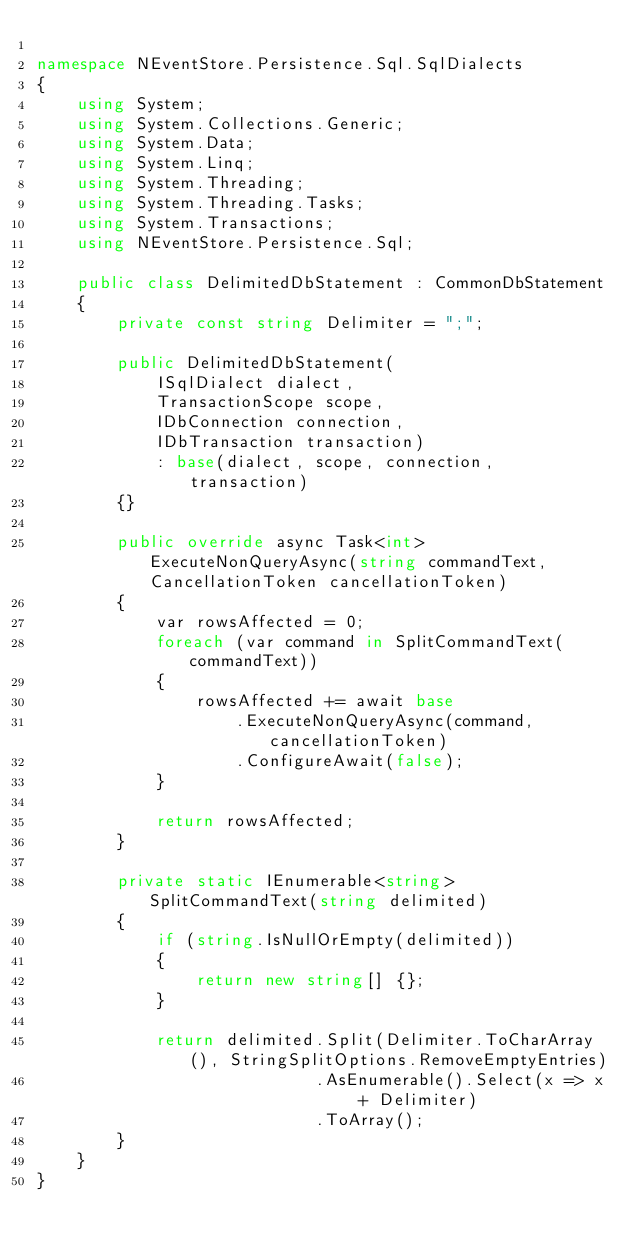<code> <loc_0><loc_0><loc_500><loc_500><_C#_>
namespace NEventStore.Persistence.Sql.SqlDialects
{
    using System;
    using System.Collections.Generic;
    using System.Data;
    using System.Linq;
    using System.Threading;
    using System.Threading.Tasks;
    using System.Transactions;
    using NEventStore.Persistence.Sql;

    public class DelimitedDbStatement : CommonDbStatement
    {
        private const string Delimiter = ";";

        public DelimitedDbStatement(
            ISqlDialect dialect,
            TransactionScope scope,
            IDbConnection connection,
            IDbTransaction transaction)
            : base(dialect, scope, connection, transaction)
        {}

        public override async Task<int> ExecuteNonQueryAsync(string commandText, CancellationToken cancellationToken)
        {
            var rowsAffected = 0;
            foreach (var command in SplitCommandText(commandText))
            {
                rowsAffected += await base
                    .ExecuteNonQueryAsync(command, cancellationToken)
                    .ConfigureAwait(false);
            }

            return rowsAffected;
        }

        private static IEnumerable<string> SplitCommandText(string delimited)
        {
            if (string.IsNullOrEmpty(delimited))
            {
                return new string[] {};
            }

            return delimited.Split(Delimiter.ToCharArray(), StringSplitOptions.RemoveEmptyEntries)
                            .AsEnumerable().Select(x => x + Delimiter)
                            .ToArray();
        }
    }
}</code> 